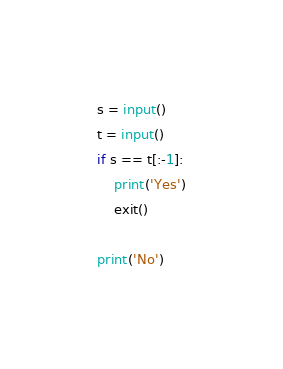Convert code to text. <code><loc_0><loc_0><loc_500><loc_500><_Python_>s = input()
t = input()
if s == t[:-1]:
    print('Yes')
    exit()

print('No')</code> 